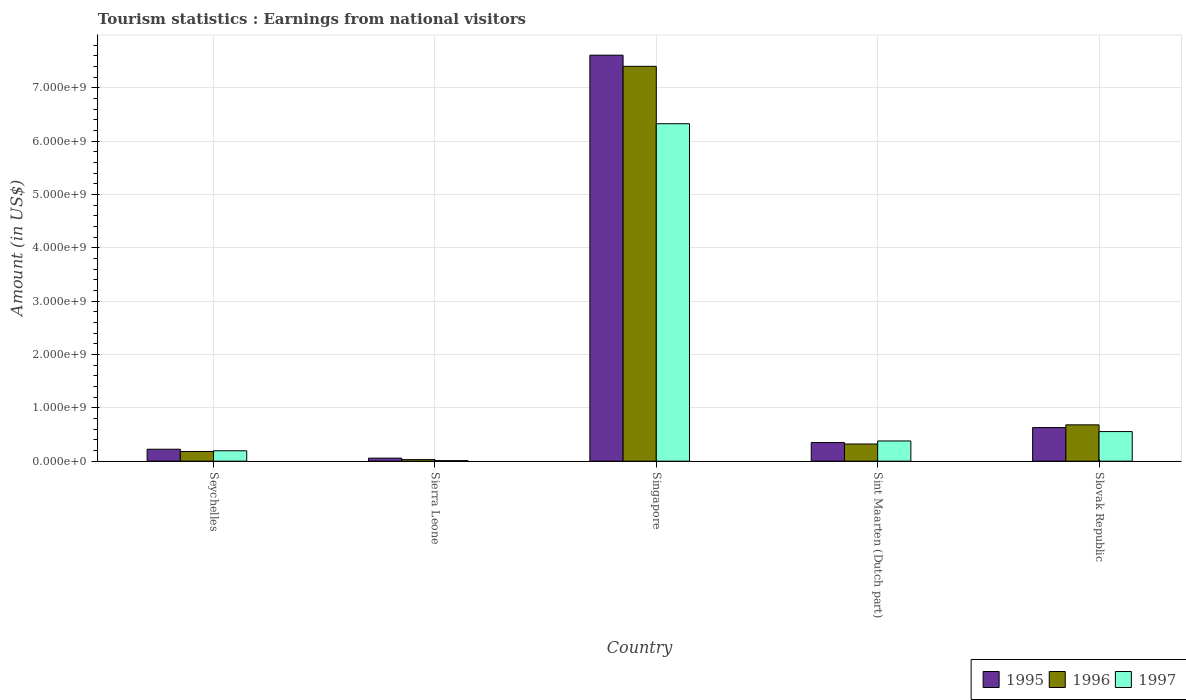Are the number of bars per tick equal to the number of legend labels?
Your answer should be very brief. Yes. Are the number of bars on each tick of the X-axis equal?
Give a very brief answer. Yes. How many bars are there on the 4th tick from the left?
Keep it short and to the point. 3. What is the label of the 1st group of bars from the left?
Your answer should be compact. Seychelles. What is the earnings from national visitors in 1995 in Seychelles?
Your response must be concise. 2.24e+08. Across all countries, what is the maximum earnings from national visitors in 1997?
Your answer should be compact. 6.33e+09. Across all countries, what is the minimum earnings from national visitors in 1996?
Make the answer very short. 2.90e+07. In which country was the earnings from national visitors in 1995 maximum?
Your response must be concise. Singapore. In which country was the earnings from national visitors in 1995 minimum?
Give a very brief answer. Sierra Leone. What is the total earnings from national visitors in 1996 in the graph?
Your response must be concise. 8.62e+09. What is the difference between the earnings from national visitors in 1997 in Sierra Leone and that in Singapore?
Offer a terse response. -6.32e+09. What is the difference between the earnings from national visitors in 1997 in Slovak Republic and the earnings from national visitors in 1996 in Sint Maarten (Dutch part)?
Your answer should be very brief. 2.33e+08. What is the average earnings from national visitors in 1996 per country?
Give a very brief answer. 1.72e+09. What is the difference between the earnings from national visitors of/in 1996 and earnings from national visitors of/in 1995 in Singapore?
Ensure brevity in your answer.  -2.09e+08. In how many countries, is the earnings from national visitors in 1996 greater than 4000000000 US$?
Offer a very short reply. 1. What is the ratio of the earnings from national visitors in 1997 in Sierra Leone to that in Sint Maarten (Dutch part)?
Offer a very short reply. 0.03. Is the earnings from national visitors in 1997 in Seychelles less than that in Sierra Leone?
Your answer should be compact. No. What is the difference between the highest and the second highest earnings from national visitors in 1996?
Ensure brevity in your answer.  6.72e+09. What is the difference between the highest and the lowest earnings from national visitors in 1996?
Offer a terse response. 7.37e+09. Is the sum of the earnings from national visitors in 1995 in Seychelles and Singapore greater than the maximum earnings from national visitors in 1997 across all countries?
Offer a terse response. Yes. What does the 1st bar from the left in Sierra Leone represents?
Your answer should be compact. 1995. What does the 2nd bar from the right in Sierra Leone represents?
Ensure brevity in your answer.  1996. How many bars are there?
Your response must be concise. 15. Are the values on the major ticks of Y-axis written in scientific E-notation?
Provide a short and direct response. Yes. Does the graph contain grids?
Provide a short and direct response. Yes. Where does the legend appear in the graph?
Give a very brief answer. Bottom right. What is the title of the graph?
Keep it short and to the point. Tourism statistics : Earnings from national visitors. What is the Amount (in US$) of 1995 in Seychelles?
Offer a very short reply. 2.24e+08. What is the Amount (in US$) in 1996 in Seychelles?
Provide a succinct answer. 1.82e+08. What is the Amount (in US$) in 1997 in Seychelles?
Your answer should be compact. 1.95e+08. What is the Amount (in US$) of 1995 in Sierra Leone?
Make the answer very short. 5.70e+07. What is the Amount (in US$) of 1996 in Sierra Leone?
Keep it short and to the point. 2.90e+07. What is the Amount (in US$) in 1995 in Singapore?
Keep it short and to the point. 7.61e+09. What is the Amount (in US$) in 1996 in Singapore?
Your response must be concise. 7.40e+09. What is the Amount (in US$) in 1997 in Singapore?
Provide a succinct answer. 6.33e+09. What is the Amount (in US$) of 1995 in Sint Maarten (Dutch part)?
Make the answer very short. 3.49e+08. What is the Amount (in US$) in 1996 in Sint Maarten (Dutch part)?
Your response must be concise. 3.22e+08. What is the Amount (in US$) of 1997 in Sint Maarten (Dutch part)?
Your answer should be very brief. 3.79e+08. What is the Amount (in US$) in 1995 in Slovak Republic?
Keep it short and to the point. 6.30e+08. What is the Amount (in US$) of 1996 in Slovak Republic?
Provide a short and direct response. 6.81e+08. What is the Amount (in US$) in 1997 in Slovak Republic?
Your answer should be compact. 5.55e+08. Across all countries, what is the maximum Amount (in US$) in 1995?
Keep it short and to the point. 7.61e+09. Across all countries, what is the maximum Amount (in US$) in 1996?
Make the answer very short. 7.40e+09. Across all countries, what is the maximum Amount (in US$) of 1997?
Provide a succinct answer. 6.33e+09. Across all countries, what is the minimum Amount (in US$) of 1995?
Provide a short and direct response. 5.70e+07. Across all countries, what is the minimum Amount (in US$) of 1996?
Give a very brief answer. 2.90e+07. What is the total Amount (in US$) of 1995 in the graph?
Provide a short and direct response. 8.87e+09. What is the total Amount (in US$) in 1996 in the graph?
Provide a short and direct response. 8.62e+09. What is the total Amount (in US$) of 1997 in the graph?
Offer a very short reply. 7.46e+09. What is the difference between the Amount (in US$) of 1995 in Seychelles and that in Sierra Leone?
Provide a short and direct response. 1.67e+08. What is the difference between the Amount (in US$) in 1996 in Seychelles and that in Sierra Leone?
Provide a succinct answer. 1.53e+08. What is the difference between the Amount (in US$) of 1997 in Seychelles and that in Sierra Leone?
Give a very brief answer. 1.85e+08. What is the difference between the Amount (in US$) in 1995 in Seychelles and that in Singapore?
Your response must be concise. -7.39e+09. What is the difference between the Amount (in US$) of 1996 in Seychelles and that in Singapore?
Offer a terse response. -7.22e+09. What is the difference between the Amount (in US$) of 1997 in Seychelles and that in Singapore?
Provide a short and direct response. -6.13e+09. What is the difference between the Amount (in US$) of 1995 in Seychelles and that in Sint Maarten (Dutch part)?
Keep it short and to the point. -1.25e+08. What is the difference between the Amount (in US$) of 1996 in Seychelles and that in Sint Maarten (Dutch part)?
Ensure brevity in your answer.  -1.40e+08. What is the difference between the Amount (in US$) in 1997 in Seychelles and that in Sint Maarten (Dutch part)?
Your response must be concise. -1.84e+08. What is the difference between the Amount (in US$) in 1995 in Seychelles and that in Slovak Republic?
Provide a short and direct response. -4.06e+08. What is the difference between the Amount (in US$) in 1996 in Seychelles and that in Slovak Republic?
Provide a succinct answer. -4.99e+08. What is the difference between the Amount (in US$) of 1997 in Seychelles and that in Slovak Republic?
Your answer should be very brief. -3.60e+08. What is the difference between the Amount (in US$) of 1995 in Sierra Leone and that in Singapore?
Provide a short and direct response. -7.55e+09. What is the difference between the Amount (in US$) in 1996 in Sierra Leone and that in Singapore?
Your response must be concise. -7.37e+09. What is the difference between the Amount (in US$) in 1997 in Sierra Leone and that in Singapore?
Make the answer very short. -6.32e+09. What is the difference between the Amount (in US$) of 1995 in Sierra Leone and that in Sint Maarten (Dutch part)?
Keep it short and to the point. -2.92e+08. What is the difference between the Amount (in US$) of 1996 in Sierra Leone and that in Sint Maarten (Dutch part)?
Offer a very short reply. -2.93e+08. What is the difference between the Amount (in US$) of 1997 in Sierra Leone and that in Sint Maarten (Dutch part)?
Keep it short and to the point. -3.69e+08. What is the difference between the Amount (in US$) of 1995 in Sierra Leone and that in Slovak Republic?
Give a very brief answer. -5.73e+08. What is the difference between the Amount (in US$) of 1996 in Sierra Leone and that in Slovak Republic?
Your answer should be very brief. -6.52e+08. What is the difference between the Amount (in US$) in 1997 in Sierra Leone and that in Slovak Republic?
Offer a very short reply. -5.45e+08. What is the difference between the Amount (in US$) in 1995 in Singapore and that in Sint Maarten (Dutch part)?
Your answer should be very brief. 7.26e+09. What is the difference between the Amount (in US$) in 1996 in Singapore and that in Sint Maarten (Dutch part)?
Provide a short and direct response. 7.08e+09. What is the difference between the Amount (in US$) in 1997 in Singapore and that in Sint Maarten (Dutch part)?
Make the answer very short. 5.95e+09. What is the difference between the Amount (in US$) in 1995 in Singapore and that in Slovak Republic?
Your answer should be compact. 6.98e+09. What is the difference between the Amount (in US$) of 1996 in Singapore and that in Slovak Republic?
Your response must be concise. 6.72e+09. What is the difference between the Amount (in US$) in 1997 in Singapore and that in Slovak Republic?
Offer a very short reply. 5.77e+09. What is the difference between the Amount (in US$) of 1995 in Sint Maarten (Dutch part) and that in Slovak Republic?
Provide a succinct answer. -2.81e+08. What is the difference between the Amount (in US$) in 1996 in Sint Maarten (Dutch part) and that in Slovak Republic?
Offer a very short reply. -3.59e+08. What is the difference between the Amount (in US$) in 1997 in Sint Maarten (Dutch part) and that in Slovak Republic?
Your response must be concise. -1.76e+08. What is the difference between the Amount (in US$) of 1995 in Seychelles and the Amount (in US$) of 1996 in Sierra Leone?
Ensure brevity in your answer.  1.95e+08. What is the difference between the Amount (in US$) in 1995 in Seychelles and the Amount (in US$) in 1997 in Sierra Leone?
Make the answer very short. 2.14e+08. What is the difference between the Amount (in US$) in 1996 in Seychelles and the Amount (in US$) in 1997 in Sierra Leone?
Your response must be concise. 1.72e+08. What is the difference between the Amount (in US$) of 1995 in Seychelles and the Amount (in US$) of 1996 in Singapore?
Provide a short and direct response. -7.18e+09. What is the difference between the Amount (in US$) in 1995 in Seychelles and the Amount (in US$) in 1997 in Singapore?
Ensure brevity in your answer.  -6.10e+09. What is the difference between the Amount (in US$) in 1996 in Seychelles and the Amount (in US$) in 1997 in Singapore?
Keep it short and to the point. -6.14e+09. What is the difference between the Amount (in US$) in 1995 in Seychelles and the Amount (in US$) in 1996 in Sint Maarten (Dutch part)?
Ensure brevity in your answer.  -9.80e+07. What is the difference between the Amount (in US$) of 1995 in Seychelles and the Amount (in US$) of 1997 in Sint Maarten (Dutch part)?
Provide a succinct answer. -1.55e+08. What is the difference between the Amount (in US$) in 1996 in Seychelles and the Amount (in US$) in 1997 in Sint Maarten (Dutch part)?
Offer a terse response. -1.97e+08. What is the difference between the Amount (in US$) in 1995 in Seychelles and the Amount (in US$) in 1996 in Slovak Republic?
Your response must be concise. -4.57e+08. What is the difference between the Amount (in US$) in 1995 in Seychelles and the Amount (in US$) in 1997 in Slovak Republic?
Your answer should be very brief. -3.31e+08. What is the difference between the Amount (in US$) of 1996 in Seychelles and the Amount (in US$) of 1997 in Slovak Republic?
Ensure brevity in your answer.  -3.73e+08. What is the difference between the Amount (in US$) in 1995 in Sierra Leone and the Amount (in US$) in 1996 in Singapore?
Offer a terse response. -7.34e+09. What is the difference between the Amount (in US$) of 1995 in Sierra Leone and the Amount (in US$) of 1997 in Singapore?
Provide a succinct answer. -6.27e+09. What is the difference between the Amount (in US$) in 1996 in Sierra Leone and the Amount (in US$) in 1997 in Singapore?
Your answer should be very brief. -6.30e+09. What is the difference between the Amount (in US$) in 1995 in Sierra Leone and the Amount (in US$) in 1996 in Sint Maarten (Dutch part)?
Your answer should be compact. -2.65e+08. What is the difference between the Amount (in US$) in 1995 in Sierra Leone and the Amount (in US$) in 1997 in Sint Maarten (Dutch part)?
Your response must be concise. -3.22e+08. What is the difference between the Amount (in US$) in 1996 in Sierra Leone and the Amount (in US$) in 1997 in Sint Maarten (Dutch part)?
Offer a very short reply. -3.50e+08. What is the difference between the Amount (in US$) of 1995 in Sierra Leone and the Amount (in US$) of 1996 in Slovak Republic?
Ensure brevity in your answer.  -6.24e+08. What is the difference between the Amount (in US$) in 1995 in Sierra Leone and the Amount (in US$) in 1997 in Slovak Republic?
Your answer should be very brief. -4.98e+08. What is the difference between the Amount (in US$) in 1996 in Sierra Leone and the Amount (in US$) in 1997 in Slovak Republic?
Give a very brief answer. -5.26e+08. What is the difference between the Amount (in US$) of 1995 in Singapore and the Amount (in US$) of 1996 in Sint Maarten (Dutch part)?
Keep it short and to the point. 7.29e+09. What is the difference between the Amount (in US$) in 1995 in Singapore and the Amount (in US$) in 1997 in Sint Maarten (Dutch part)?
Your answer should be compact. 7.23e+09. What is the difference between the Amount (in US$) of 1996 in Singapore and the Amount (in US$) of 1997 in Sint Maarten (Dutch part)?
Your answer should be very brief. 7.02e+09. What is the difference between the Amount (in US$) in 1995 in Singapore and the Amount (in US$) in 1996 in Slovak Republic?
Offer a very short reply. 6.93e+09. What is the difference between the Amount (in US$) in 1995 in Singapore and the Amount (in US$) in 1997 in Slovak Republic?
Keep it short and to the point. 7.06e+09. What is the difference between the Amount (in US$) in 1996 in Singapore and the Amount (in US$) in 1997 in Slovak Republic?
Give a very brief answer. 6.85e+09. What is the difference between the Amount (in US$) in 1995 in Sint Maarten (Dutch part) and the Amount (in US$) in 1996 in Slovak Republic?
Make the answer very short. -3.32e+08. What is the difference between the Amount (in US$) of 1995 in Sint Maarten (Dutch part) and the Amount (in US$) of 1997 in Slovak Republic?
Your answer should be compact. -2.06e+08. What is the difference between the Amount (in US$) of 1996 in Sint Maarten (Dutch part) and the Amount (in US$) of 1997 in Slovak Republic?
Give a very brief answer. -2.33e+08. What is the average Amount (in US$) of 1995 per country?
Offer a very short reply. 1.77e+09. What is the average Amount (in US$) in 1996 per country?
Give a very brief answer. 1.72e+09. What is the average Amount (in US$) in 1997 per country?
Your response must be concise. 1.49e+09. What is the difference between the Amount (in US$) of 1995 and Amount (in US$) of 1996 in Seychelles?
Provide a short and direct response. 4.20e+07. What is the difference between the Amount (in US$) of 1995 and Amount (in US$) of 1997 in Seychelles?
Offer a terse response. 2.90e+07. What is the difference between the Amount (in US$) of 1996 and Amount (in US$) of 1997 in Seychelles?
Keep it short and to the point. -1.30e+07. What is the difference between the Amount (in US$) of 1995 and Amount (in US$) of 1996 in Sierra Leone?
Make the answer very short. 2.80e+07. What is the difference between the Amount (in US$) of 1995 and Amount (in US$) of 1997 in Sierra Leone?
Keep it short and to the point. 4.70e+07. What is the difference between the Amount (in US$) in 1996 and Amount (in US$) in 1997 in Sierra Leone?
Offer a terse response. 1.90e+07. What is the difference between the Amount (in US$) in 1995 and Amount (in US$) in 1996 in Singapore?
Offer a very short reply. 2.09e+08. What is the difference between the Amount (in US$) in 1995 and Amount (in US$) in 1997 in Singapore?
Give a very brief answer. 1.28e+09. What is the difference between the Amount (in US$) of 1996 and Amount (in US$) of 1997 in Singapore?
Make the answer very short. 1.08e+09. What is the difference between the Amount (in US$) in 1995 and Amount (in US$) in 1996 in Sint Maarten (Dutch part)?
Ensure brevity in your answer.  2.70e+07. What is the difference between the Amount (in US$) in 1995 and Amount (in US$) in 1997 in Sint Maarten (Dutch part)?
Give a very brief answer. -3.00e+07. What is the difference between the Amount (in US$) of 1996 and Amount (in US$) of 1997 in Sint Maarten (Dutch part)?
Offer a terse response. -5.70e+07. What is the difference between the Amount (in US$) in 1995 and Amount (in US$) in 1996 in Slovak Republic?
Provide a succinct answer. -5.10e+07. What is the difference between the Amount (in US$) of 1995 and Amount (in US$) of 1997 in Slovak Republic?
Your response must be concise. 7.50e+07. What is the difference between the Amount (in US$) of 1996 and Amount (in US$) of 1997 in Slovak Republic?
Make the answer very short. 1.26e+08. What is the ratio of the Amount (in US$) of 1995 in Seychelles to that in Sierra Leone?
Give a very brief answer. 3.93. What is the ratio of the Amount (in US$) of 1996 in Seychelles to that in Sierra Leone?
Provide a succinct answer. 6.28. What is the ratio of the Amount (in US$) in 1995 in Seychelles to that in Singapore?
Your answer should be compact. 0.03. What is the ratio of the Amount (in US$) in 1996 in Seychelles to that in Singapore?
Offer a very short reply. 0.02. What is the ratio of the Amount (in US$) of 1997 in Seychelles to that in Singapore?
Offer a very short reply. 0.03. What is the ratio of the Amount (in US$) in 1995 in Seychelles to that in Sint Maarten (Dutch part)?
Provide a short and direct response. 0.64. What is the ratio of the Amount (in US$) in 1996 in Seychelles to that in Sint Maarten (Dutch part)?
Give a very brief answer. 0.57. What is the ratio of the Amount (in US$) of 1997 in Seychelles to that in Sint Maarten (Dutch part)?
Your response must be concise. 0.51. What is the ratio of the Amount (in US$) in 1995 in Seychelles to that in Slovak Republic?
Your answer should be very brief. 0.36. What is the ratio of the Amount (in US$) of 1996 in Seychelles to that in Slovak Republic?
Provide a short and direct response. 0.27. What is the ratio of the Amount (in US$) in 1997 in Seychelles to that in Slovak Republic?
Keep it short and to the point. 0.35. What is the ratio of the Amount (in US$) in 1995 in Sierra Leone to that in Singapore?
Make the answer very short. 0.01. What is the ratio of the Amount (in US$) in 1996 in Sierra Leone to that in Singapore?
Your answer should be compact. 0. What is the ratio of the Amount (in US$) in 1997 in Sierra Leone to that in Singapore?
Make the answer very short. 0. What is the ratio of the Amount (in US$) in 1995 in Sierra Leone to that in Sint Maarten (Dutch part)?
Ensure brevity in your answer.  0.16. What is the ratio of the Amount (in US$) in 1996 in Sierra Leone to that in Sint Maarten (Dutch part)?
Offer a very short reply. 0.09. What is the ratio of the Amount (in US$) in 1997 in Sierra Leone to that in Sint Maarten (Dutch part)?
Keep it short and to the point. 0.03. What is the ratio of the Amount (in US$) of 1995 in Sierra Leone to that in Slovak Republic?
Your response must be concise. 0.09. What is the ratio of the Amount (in US$) of 1996 in Sierra Leone to that in Slovak Republic?
Your response must be concise. 0.04. What is the ratio of the Amount (in US$) in 1997 in Sierra Leone to that in Slovak Republic?
Keep it short and to the point. 0.02. What is the ratio of the Amount (in US$) in 1995 in Singapore to that in Sint Maarten (Dutch part)?
Give a very brief answer. 21.81. What is the ratio of the Amount (in US$) of 1996 in Singapore to that in Sint Maarten (Dutch part)?
Your answer should be compact. 22.99. What is the ratio of the Amount (in US$) of 1997 in Singapore to that in Sint Maarten (Dutch part)?
Provide a short and direct response. 16.69. What is the ratio of the Amount (in US$) of 1995 in Singapore to that in Slovak Republic?
Provide a short and direct response. 12.08. What is the ratio of the Amount (in US$) in 1996 in Singapore to that in Slovak Republic?
Ensure brevity in your answer.  10.87. What is the ratio of the Amount (in US$) of 1997 in Singapore to that in Slovak Republic?
Your response must be concise. 11.4. What is the ratio of the Amount (in US$) in 1995 in Sint Maarten (Dutch part) to that in Slovak Republic?
Provide a succinct answer. 0.55. What is the ratio of the Amount (in US$) of 1996 in Sint Maarten (Dutch part) to that in Slovak Republic?
Offer a very short reply. 0.47. What is the ratio of the Amount (in US$) of 1997 in Sint Maarten (Dutch part) to that in Slovak Republic?
Offer a terse response. 0.68. What is the difference between the highest and the second highest Amount (in US$) in 1995?
Make the answer very short. 6.98e+09. What is the difference between the highest and the second highest Amount (in US$) in 1996?
Your answer should be very brief. 6.72e+09. What is the difference between the highest and the second highest Amount (in US$) of 1997?
Your answer should be very brief. 5.77e+09. What is the difference between the highest and the lowest Amount (in US$) in 1995?
Ensure brevity in your answer.  7.55e+09. What is the difference between the highest and the lowest Amount (in US$) in 1996?
Keep it short and to the point. 7.37e+09. What is the difference between the highest and the lowest Amount (in US$) of 1997?
Your answer should be compact. 6.32e+09. 